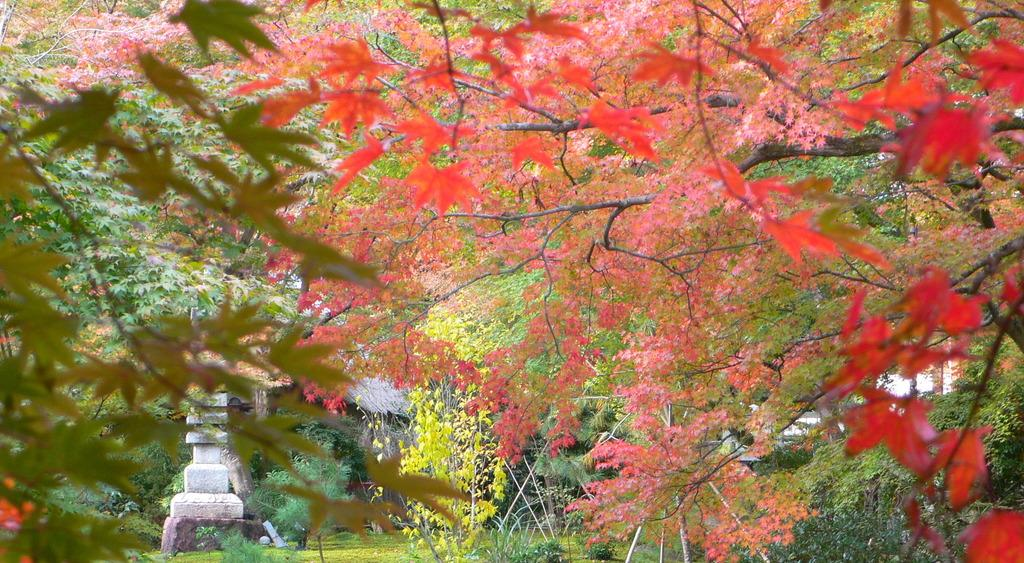What type of natural environment is depicted in the image? There are many trees, plants, and grass in the image, suggesting a natural environment. What type of building is present in the image? There is a house in the image. What other structures can be seen in the image? There is a structure in the image. What type of creature is shown interacting with the house in the image? There is no creature present in the image; it only features trees, plants, grass, a house, and a structure. What type of can is visible in the image? There is no can present in the image. 